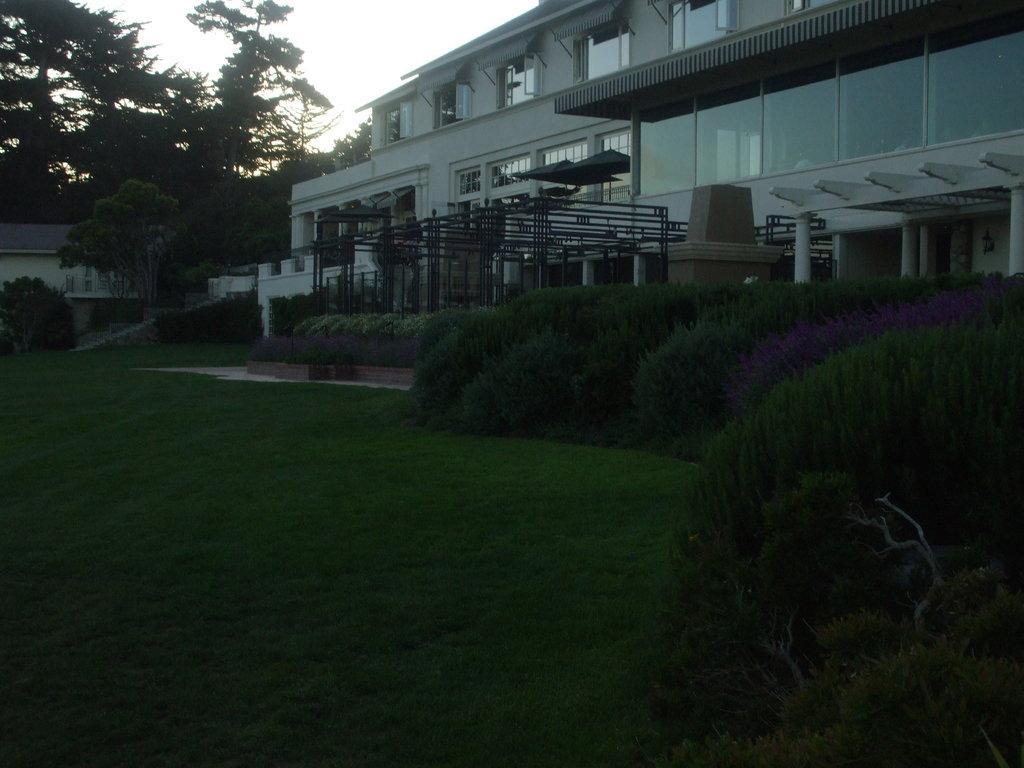Could you give a brief overview of what you see in this image? In this image we can see buildings with the windows, there are poles, plants, trees and grass, in the background we can see the sky. 